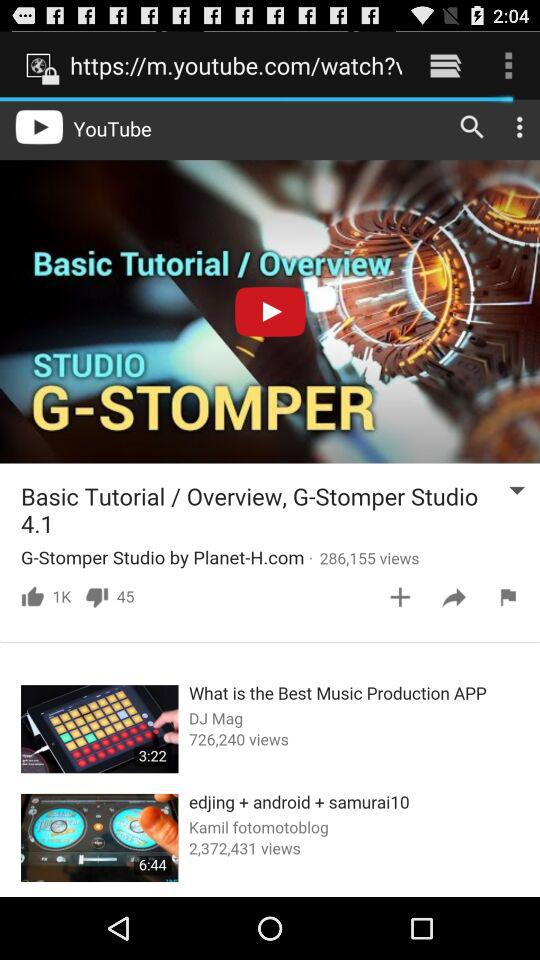How many dislikes did "G-Stomper Studio by Planet-H.com" get? G-Stomper studio by Planet-H.com got 45 dislikes. 